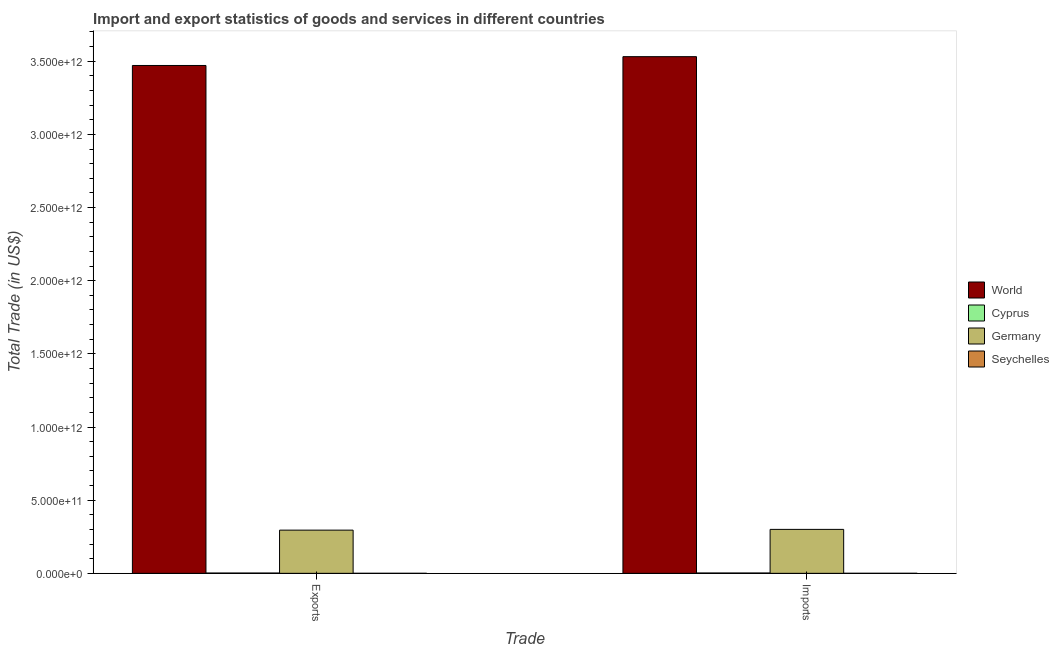How many different coloured bars are there?
Give a very brief answer. 4. Are the number of bars on each tick of the X-axis equal?
Offer a terse response. Yes. What is the label of the 1st group of bars from the left?
Your answer should be compact. Exports. What is the export of goods and services in Germany?
Your answer should be very brief. 2.95e+11. Across all countries, what is the maximum export of goods and services?
Keep it short and to the point. 3.47e+12. Across all countries, what is the minimum export of goods and services?
Make the answer very short. 3.18e+07. In which country was the imports of goods and services minimum?
Your answer should be very brief. Seychelles. What is the total imports of goods and services in the graph?
Ensure brevity in your answer.  3.83e+12. What is the difference between the export of goods and services in Germany and that in Cyprus?
Offer a terse response. 2.93e+11. What is the difference between the imports of goods and services in Seychelles and the export of goods and services in World?
Keep it short and to the point. -3.47e+12. What is the average imports of goods and services per country?
Provide a succinct answer. 9.59e+11. What is the difference between the imports of goods and services and export of goods and services in Cyprus?
Your answer should be very brief. 2.32e+08. In how many countries, is the export of goods and services greater than 900000000000 US$?
Your response must be concise. 1. What is the ratio of the export of goods and services in Germany to that in World?
Keep it short and to the point. 0.09. Is the imports of goods and services in Cyprus less than that in Germany?
Your response must be concise. Yes. What does the 2nd bar from the left in Imports represents?
Your answer should be very brief. Cyprus. How many bars are there?
Give a very brief answer. 8. Are all the bars in the graph horizontal?
Keep it short and to the point. No. How many countries are there in the graph?
Your answer should be compact. 4. What is the difference between two consecutive major ticks on the Y-axis?
Your answer should be compact. 5.00e+11. Does the graph contain grids?
Offer a very short reply. No. Where does the legend appear in the graph?
Keep it short and to the point. Center right. How are the legend labels stacked?
Offer a terse response. Vertical. What is the title of the graph?
Make the answer very short. Import and export statistics of goods and services in different countries. What is the label or title of the X-axis?
Provide a short and direct response. Trade. What is the label or title of the Y-axis?
Your answer should be very brief. Total Trade (in US$). What is the Total Trade (in US$) in World in Exports?
Keep it short and to the point. 3.47e+12. What is the Total Trade (in US$) of Cyprus in Exports?
Provide a short and direct response. 2.06e+09. What is the Total Trade (in US$) of Germany in Exports?
Keep it short and to the point. 2.95e+11. What is the Total Trade (in US$) of Seychelles in Exports?
Your answer should be very brief. 3.18e+07. What is the Total Trade (in US$) of World in Imports?
Provide a short and direct response. 3.53e+12. What is the Total Trade (in US$) of Cyprus in Imports?
Ensure brevity in your answer.  2.29e+09. What is the Total Trade (in US$) of Germany in Imports?
Ensure brevity in your answer.  3.00e+11. What is the Total Trade (in US$) of Seychelles in Imports?
Keep it short and to the point. 1.59e+08. Across all Trade, what is the maximum Total Trade (in US$) in World?
Your response must be concise. 3.53e+12. Across all Trade, what is the maximum Total Trade (in US$) in Cyprus?
Provide a short and direct response. 2.29e+09. Across all Trade, what is the maximum Total Trade (in US$) in Germany?
Give a very brief answer. 3.00e+11. Across all Trade, what is the maximum Total Trade (in US$) in Seychelles?
Make the answer very short. 1.59e+08. Across all Trade, what is the minimum Total Trade (in US$) of World?
Keep it short and to the point. 3.47e+12. Across all Trade, what is the minimum Total Trade (in US$) of Cyprus?
Ensure brevity in your answer.  2.06e+09. Across all Trade, what is the minimum Total Trade (in US$) of Germany?
Offer a terse response. 2.95e+11. Across all Trade, what is the minimum Total Trade (in US$) of Seychelles?
Offer a very short reply. 3.18e+07. What is the total Total Trade (in US$) of World in the graph?
Provide a succinct answer. 7.00e+12. What is the total Total Trade (in US$) in Cyprus in the graph?
Offer a very short reply. 4.35e+09. What is the total Total Trade (in US$) of Germany in the graph?
Your response must be concise. 5.96e+11. What is the total Total Trade (in US$) of Seychelles in the graph?
Offer a very short reply. 1.91e+08. What is the difference between the Total Trade (in US$) of World in Exports and that in Imports?
Make the answer very short. -6.03e+1. What is the difference between the Total Trade (in US$) of Cyprus in Exports and that in Imports?
Make the answer very short. -2.32e+08. What is the difference between the Total Trade (in US$) of Germany in Exports and that in Imports?
Make the answer very short. -5.17e+09. What is the difference between the Total Trade (in US$) in Seychelles in Exports and that in Imports?
Keep it short and to the point. -1.27e+08. What is the difference between the Total Trade (in US$) in World in Exports and the Total Trade (in US$) in Cyprus in Imports?
Give a very brief answer. 3.47e+12. What is the difference between the Total Trade (in US$) in World in Exports and the Total Trade (in US$) in Germany in Imports?
Offer a very short reply. 3.17e+12. What is the difference between the Total Trade (in US$) of World in Exports and the Total Trade (in US$) of Seychelles in Imports?
Provide a short and direct response. 3.47e+12. What is the difference between the Total Trade (in US$) of Cyprus in Exports and the Total Trade (in US$) of Germany in Imports?
Your response must be concise. -2.98e+11. What is the difference between the Total Trade (in US$) of Cyprus in Exports and the Total Trade (in US$) of Seychelles in Imports?
Provide a succinct answer. 1.90e+09. What is the difference between the Total Trade (in US$) of Germany in Exports and the Total Trade (in US$) of Seychelles in Imports?
Your answer should be compact. 2.95e+11. What is the average Total Trade (in US$) of World per Trade?
Provide a succinct answer. 3.50e+12. What is the average Total Trade (in US$) in Cyprus per Trade?
Your response must be concise. 2.17e+09. What is the average Total Trade (in US$) of Germany per Trade?
Offer a terse response. 2.98e+11. What is the average Total Trade (in US$) in Seychelles per Trade?
Provide a succinct answer. 9.55e+07. What is the difference between the Total Trade (in US$) in World and Total Trade (in US$) in Cyprus in Exports?
Ensure brevity in your answer.  3.47e+12. What is the difference between the Total Trade (in US$) of World and Total Trade (in US$) of Germany in Exports?
Your answer should be very brief. 3.18e+12. What is the difference between the Total Trade (in US$) of World and Total Trade (in US$) of Seychelles in Exports?
Make the answer very short. 3.47e+12. What is the difference between the Total Trade (in US$) of Cyprus and Total Trade (in US$) of Germany in Exports?
Your answer should be very brief. -2.93e+11. What is the difference between the Total Trade (in US$) of Cyprus and Total Trade (in US$) of Seychelles in Exports?
Provide a succinct answer. 2.03e+09. What is the difference between the Total Trade (in US$) in Germany and Total Trade (in US$) in Seychelles in Exports?
Give a very brief answer. 2.95e+11. What is the difference between the Total Trade (in US$) in World and Total Trade (in US$) in Cyprus in Imports?
Give a very brief answer. 3.53e+12. What is the difference between the Total Trade (in US$) of World and Total Trade (in US$) of Germany in Imports?
Offer a terse response. 3.23e+12. What is the difference between the Total Trade (in US$) in World and Total Trade (in US$) in Seychelles in Imports?
Provide a short and direct response. 3.53e+12. What is the difference between the Total Trade (in US$) of Cyprus and Total Trade (in US$) of Germany in Imports?
Ensure brevity in your answer.  -2.98e+11. What is the difference between the Total Trade (in US$) of Cyprus and Total Trade (in US$) of Seychelles in Imports?
Offer a terse response. 2.13e+09. What is the difference between the Total Trade (in US$) in Germany and Total Trade (in US$) in Seychelles in Imports?
Ensure brevity in your answer.  3.00e+11. What is the ratio of the Total Trade (in US$) of World in Exports to that in Imports?
Give a very brief answer. 0.98. What is the ratio of the Total Trade (in US$) of Cyprus in Exports to that in Imports?
Provide a short and direct response. 0.9. What is the ratio of the Total Trade (in US$) in Germany in Exports to that in Imports?
Make the answer very short. 0.98. What is the ratio of the Total Trade (in US$) in Seychelles in Exports to that in Imports?
Provide a succinct answer. 0.2. What is the difference between the highest and the second highest Total Trade (in US$) in World?
Give a very brief answer. 6.03e+1. What is the difference between the highest and the second highest Total Trade (in US$) of Cyprus?
Your answer should be compact. 2.32e+08. What is the difference between the highest and the second highest Total Trade (in US$) of Germany?
Offer a terse response. 5.17e+09. What is the difference between the highest and the second highest Total Trade (in US$) of Seychelles?
Your answer should be very brief. 1.27e+08. What is the difference between the highest and the lowest Total Trade (in US$) of World?
Your response must be concise. 6.03e+1. What is the difference between the highest and the lowest Total Trade (in US$) in Cyprus?
Offer a terse response. 2.32e+08. What is the difference between the highest and the lowest Total Trade (in US$) in Germany?
Offer a very short reply. 5.17e+09. What is the difference between the highest and the lowest Total Trade (in US$) in Seychelles?
Ensure brevity in your answer.  1.27e+08. 